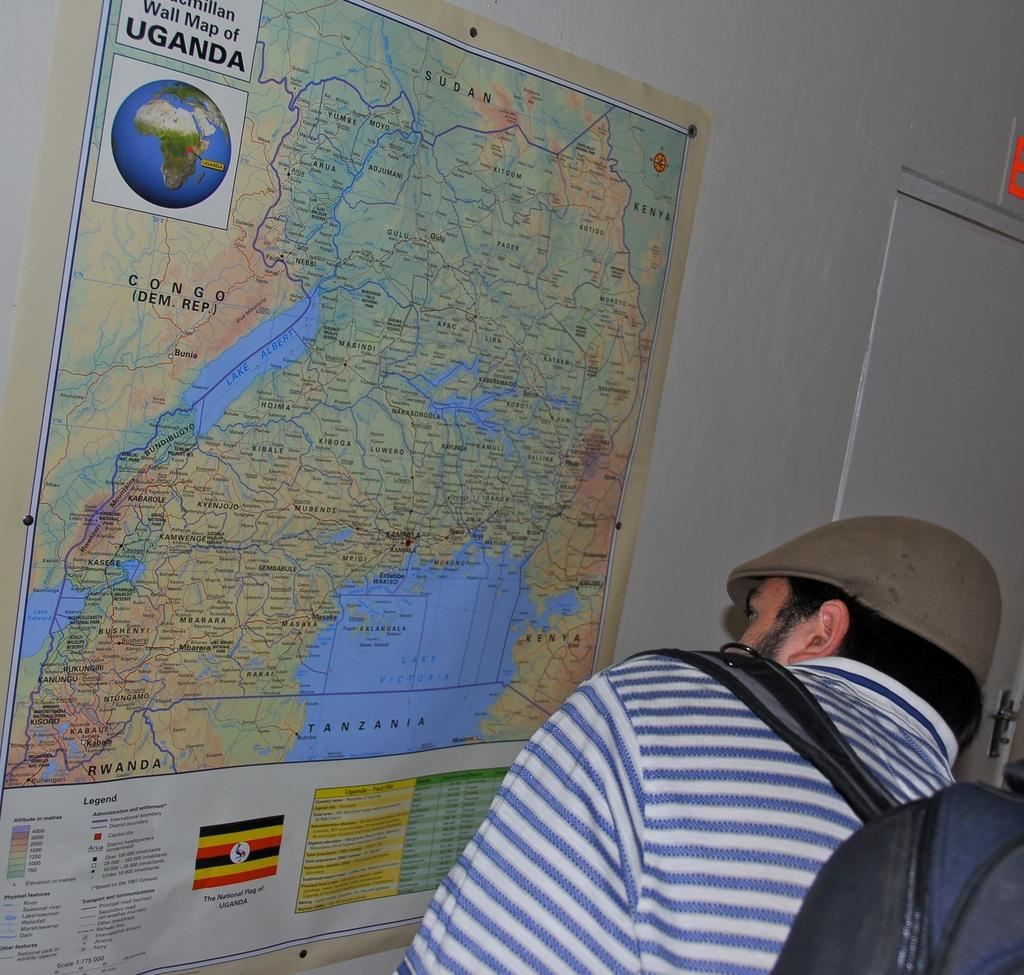Who is present in the image? There is a man in the image. What can be seen on the wall in the image? There is a map on a wall in the image. What architectural feature is visible in the image? There is a door in the image. What type of butter is being used to guide the man in the image? There is no butter present in the image, and the man is not being guided by any butter. 